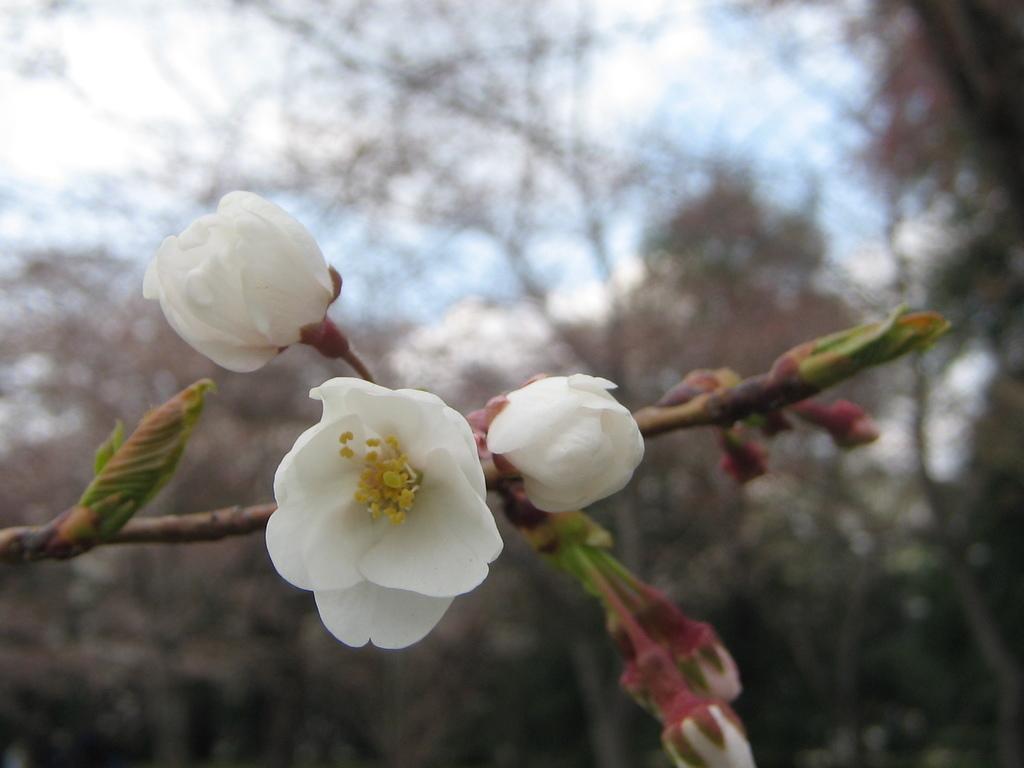In one or two sentences, can you explain what this image depicts? In this picture there are white color flowers and buds on the plant. At the back there are trees. At the top there is sky and there are clouds. 